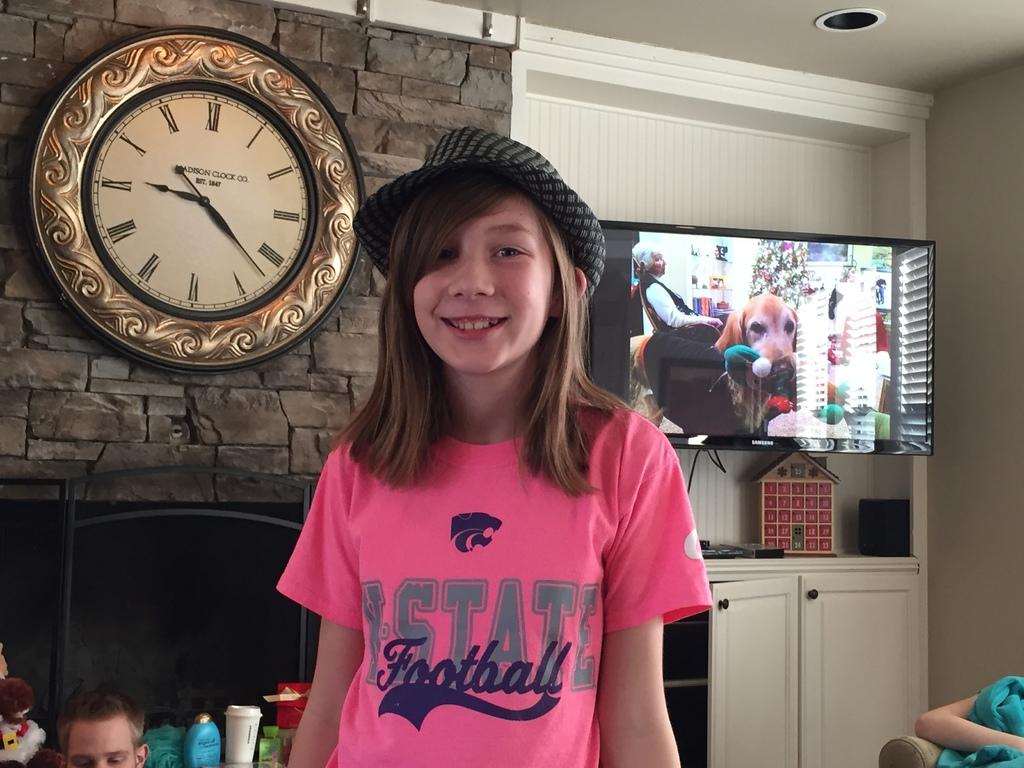What time is on the clock?
Your answer should be very brief. 9:22. 